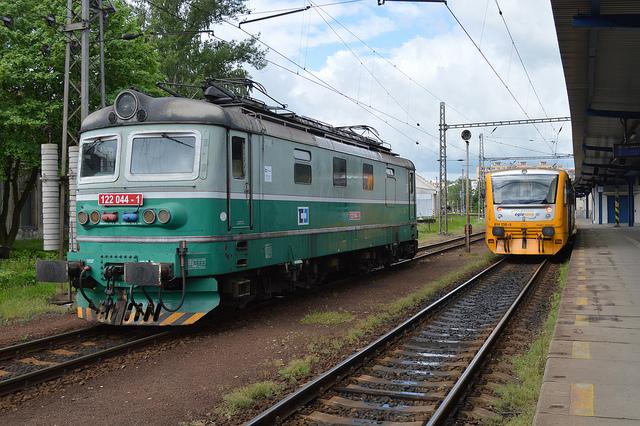What color is the train?
Answer briefly. Green. What is the train number on the left?
Answer briefly. 122 044-1. Which train is going faster?
Keep it brief. Green. What color is the train on the right painted?
Write a very short answer. Yellow. 